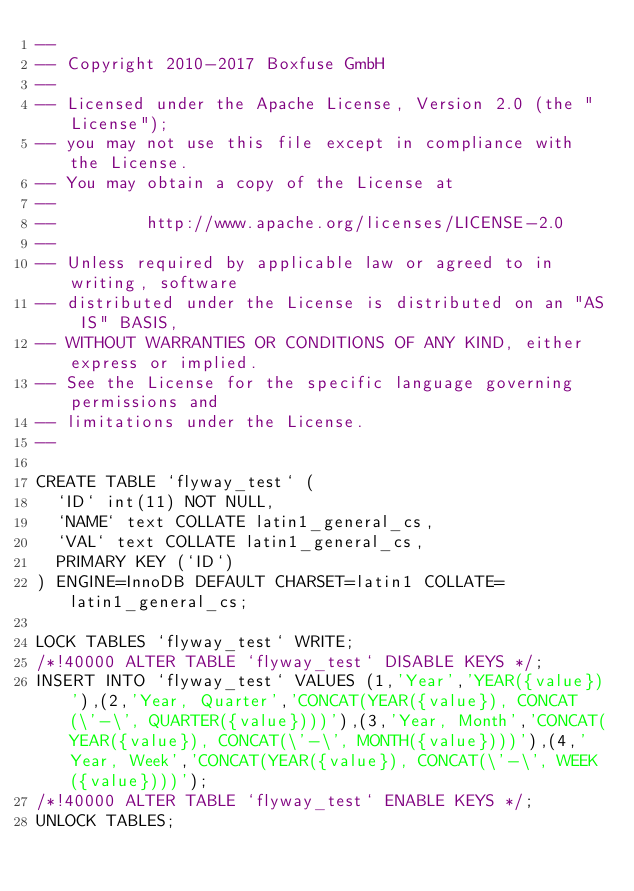<code> <loc_0><loc_0><loc_500><loc_500><_SQL_>--
-- Copyright 2010-2017 Boxfuse GmbH
--
-- Licensed under the Apache License, Version 2.0 (the "License");
-- you may not use this file except in compliance with the License.
-- You may obtain a copy of the License at
--
--         http://www.apache.org/licenses/LICENSE-2.0
--
-- Unless required by applicable law or agreed to in writing, software
-- distributed under the License is distributed on an "AS IS" BASIS,
-- WITHOUT WARRANTIES OR CONDITIONS OF ANY KIND, either express or implied.
-- See the License for the specific language governing permissions and
-- limitations under the License.
--

CREATE TABLE `flyway_test` (
  `ID` int(11) NOT NULL,
  `NAME` text COLLATE latin1_general_cs,
  `VAL` text COLLATE latin1_general_cs,
  PRIMARY KEY (`ID`)
) ENGINE=InnoDB DEFAULT CHARSET=latin1 COLLATE=latin1_general_cs;

LOCK TABLES `flyway_test` WRITE;
/*!40000 ALTER TABLE `flyway_test` DISABLE KEYS */;
INSERT INTO `flyway_test` VALUES (1,'Year','YEAR({value})'),(2,'Year, Quarter','CONCAT(YEAR({value}), CONCAT(\'-\', QUARTER({value})))'),(3,'Year, Month','CONCAT(YEAR({value}), CONCAT(\'-\', MONTH({value})))'),(4,'Year, Week','CONCAT(YEAR({value}), CONCAT(\'-\', WEEK({value})))');
/*!40000 ALTER TABLE `flyway_test` ENABLE KEYS */;
UNLOCK TABLES;</code> 